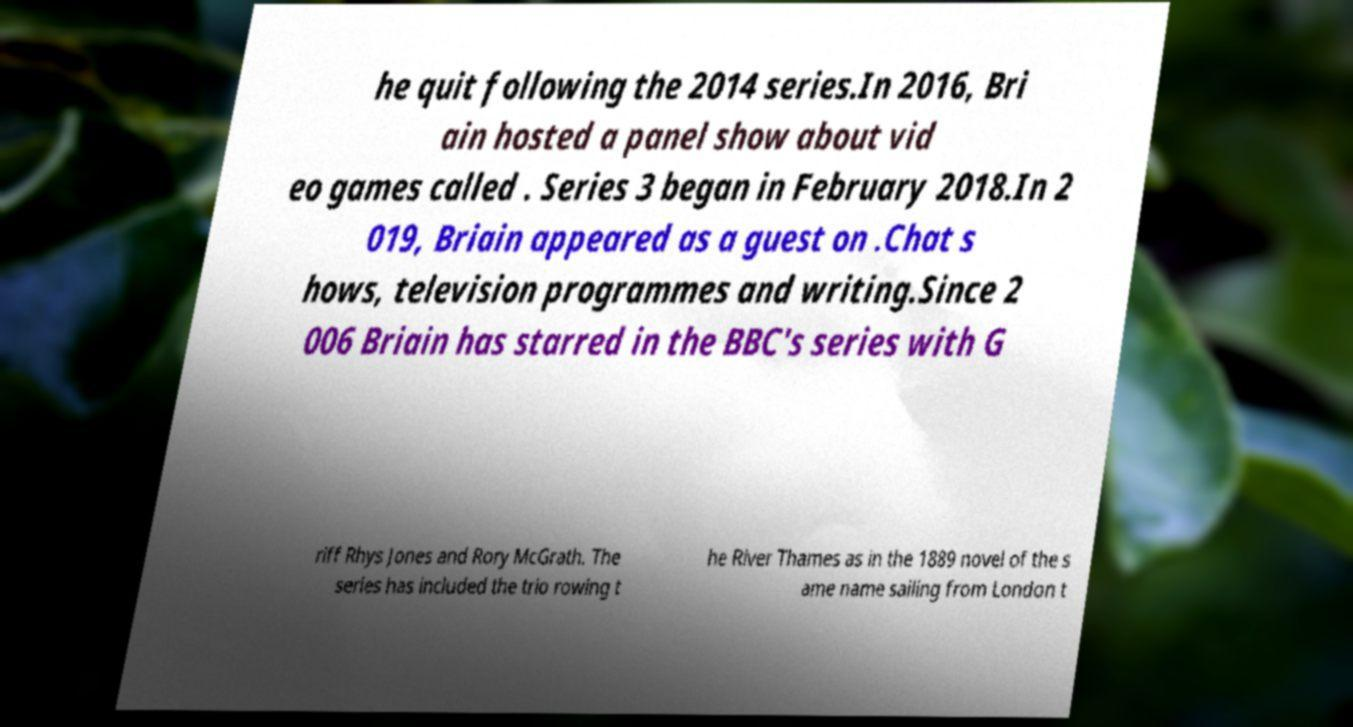Could you assist in decoding the text presented in this image and type it out clearly? he quit following the 2014 series.In 2016, Bri ain hosted a panel show about vid eo games called . Series 3 began in February 2018.In 2 019, Briain appeared as a guest on .Chat s hows, television programmes and writing.Since 2 006 Briain has starred in the BBC's series with G riff Rhys Jones and Rory McGrath. The series has included the trio rowing t he River Thames as in the 1889 novel of the s ame name sailing from London t 